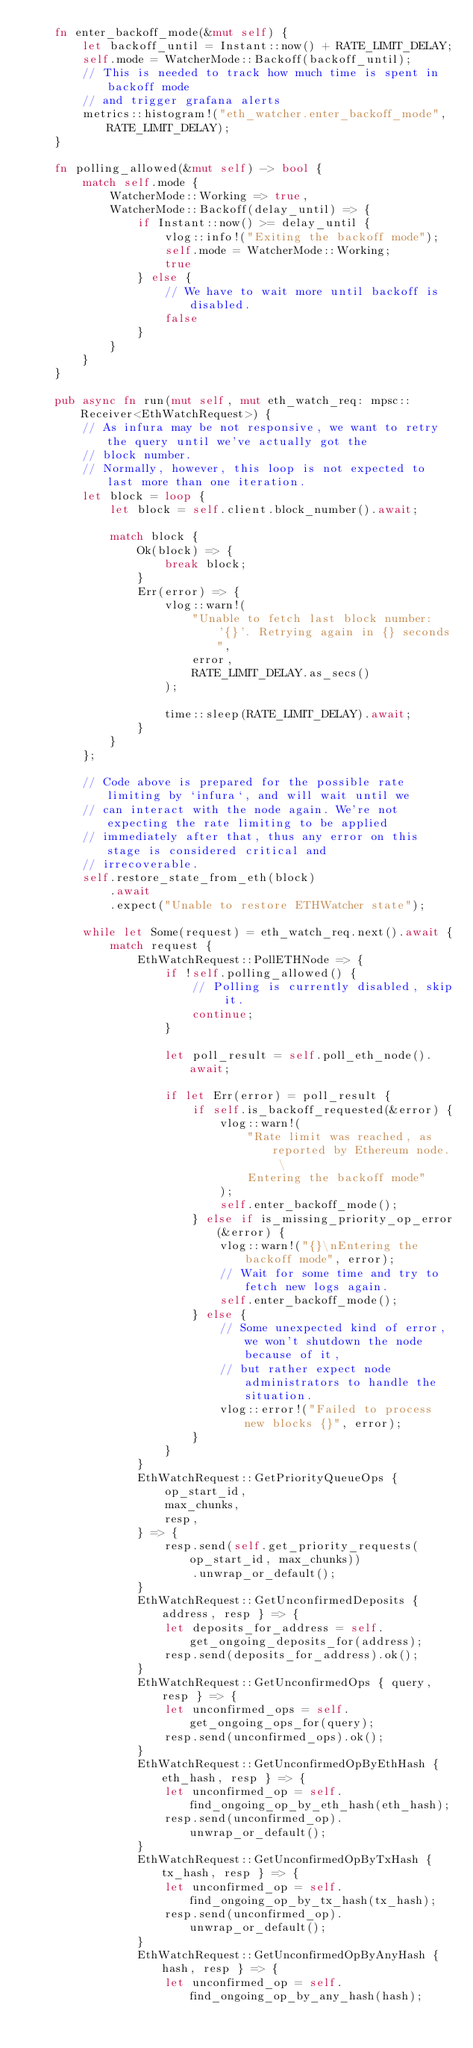Convert code to text. <code><loc_0><loc_0><loc_500><loc_500><_Rust_>    fn enter_backoff_mode(&mut self) {
        let backoff_until = Instant::now() + RATE_LIMIT_DELAY;
        self.mode = WatcherMode::Backoff(backoff_until);
        // This is needed to track how much time is spent in backoff mode
        // and trigger grafana alerts
        metrics::histogram!("eth_watcher.enter_backoff_mode", RATE_LIMIT_DELAY);
    }

    fn polling_allowed(&mut self) -> bool {
        match self.mode {
            WatcherMode::Working => true,
            WatcherMode::Backoff(delay_until) => {
                if Instant::now() >= delay_until {
                    vlog::info!("Exiting the backoff mode");
                    self.mode = WatcherMode::Working;
                    true
                } else {
                    // We have to wait more until backoff is disabled.
                    false
                }
            }
        }
    }

    pub async fn run(mut self, mut eth_watch_req: mpsc::Receiver<EthWatchRequest>) {
        // As infura may be not responsive, we want to retry the query until we've actually got the
        // block number.
        // Normally, however, this loop is not expected to last more than one iteration.
        let block = loop {
            let block = self.client.block_number().await;

            match block {
                Ok(block) => {
                    break block;
                }
                Err(error) => {
                    vlog::warn!(
                        "Unable to fetch last block number: '{}'. Retrying again in {} seconds",
                        error,
                        RATE_LIMIT_DELAY.as_secs()
                    );

                    time::sleep(RATE_LIMIT_DELAY).await;
                }
            }
        };

        // Code above is prepared for the possible rate limiting by `infura`, and will wait until we
        // can interact with the node again. We're not expecting the rate limiting to be applied
        // immediately after that, thus any error on this stage is considered critical and
        // irrecoverable.
        self.restore_state_from_eth(block)
            .await
            .expect("Unable to restore ETHWatcher state");

        while let Some(request) = eth_watch_req.next().await {
            match request {
                EthWatchRequest::PollETHNode => {
                    if !self.polling_allowed() {
                        // Polling is currently disabled, skip it.
                        continue;
                    }

                    let poll_result = self.poll_eth_node().await;

                    if let Err(error) = poll_result {
                        if self.is_backoff_requested(&error) {
                            vlog::warn!(
                                "Rate limit was reached, as reported by Ethereum node. \
                                Entering the backoff mode"
                            );
                            self.enter_backoff_mode();
                        } else if is_missing_priority_op_error(&error) {
                            vlog::warn!("{}\nEntering the backoff mode", error);
                            // Wait for some time and try to fetch new logs again.
                            self.enter_backoff_mode();
                        } else {
                            // Some unexpected kind of error, we won't shutdown the node because of it,
                            // but rather expect node administrators to handle the situation.
                            vlog::error!("Failed to process new blocks {}", error);
                        }
                    }
                }
                EthWatchRequest::GetPriorityQueueOps {
                    op_start_id,
                    max_chunks,
                    resp,
                } => {
                    resp.send(self.get_priority_requests(op_start_id, max_chunks))
                        .unwrap_or_default();
                }
                EthWatchRequest::GetUnconfirmedDeposits { address, resp } => {
                    let deposits_for_address = self.get_ongoing_deposits_for(address);
                    resp.send(deposits_for_address).ok();
                }
                EthWatchRequest::GetUnconfirmedOps { query, resp } => {
                    let unconfirmed_ops = self.get_ongoing_ops_for(query);
                    resp.send(unconfirmed_ops).ok();
                }
                EthWatchRequest::GetUnconfirmedOpByEthHash { eth_hash, resp } => {
                    let unconfirmed_op = self.find_ongoing_op_by_eth_hash(eth_hash);
                    resp.send(unconfirmed_op).unwrap_or_default();
                }
                EthWatchRequest::GetUnconfirmedOpByTxHash { tx_hash, resp } => {
                    let unconfirmed_op = self.find_ongoing_op_by_tx_hash(tx_hash);
                    resp.send(unconfirmed_op).unwrap_or_default();
                }
                EthWatchRequest::GetUnconfirmedOpByAnyHash { hash, resp } => {
                    let unconfirmed_op = self.find_ongoing_op_by_any_hash(hash);</code> 